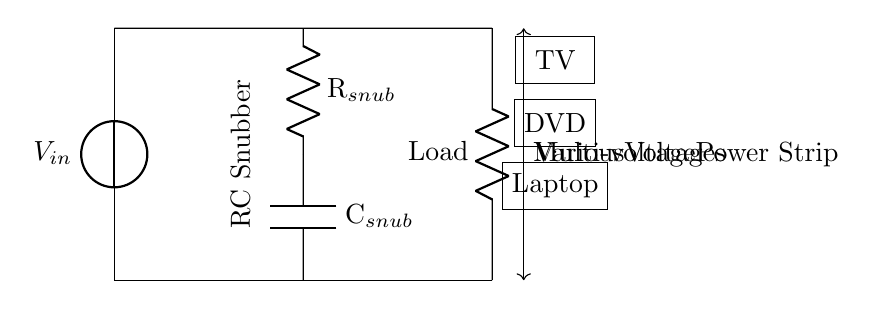What is the purpose of the RC snubber in this circuit? The RC snubber is designed to protect electrical components from voltage spikes and transients by absorbing energy and preventing sudden changes in voltage.
Answer: Protect devices What components are included in the snubber circuit? The snubber circuit consists of a resistor and a capacitor connected in series. This combination helps to dampen the effects of voltage spikes.
Answer: Resistor and capacitor What do the symbols V_in and Load represent? V_in represents the input voltage from the power source, while Load denotes the electrical device connected to the circuit that will consume the power.
Answer: Input voltage and load device How many devices are indicated as connected to the power strip? There are three devices displayed: a TV, a DVD player, and a laptop, showing that this power strip is intended for multiple devices.
Answer: Three devices What is the effect of different voltages in this circuit? The circuit is designed to handle various voltages, allowing it to protect connected devices irrespective of their individual voltage requirements.
Answer: Various voltages How would the failure of the snubber circuit affect the load? If the snubber circuit fails, voltage spikes could potentially harm the connected load, leading to damage or malfunction of electronic devices.
Answer: Damage to load 